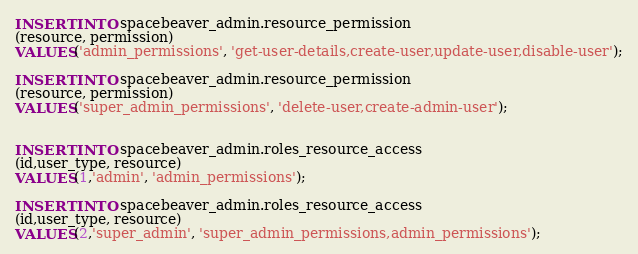<code> <loc_0><loc_0><loc_500><loc_500><_SQL_>INSERT INTO spacebeaver_admin.resource_permission
(resource, permission)
VALUES('admin_permissions', 'get-user-details,create-user,update-user,disable-user');

INSERT INTO spacebeaver_admin.resource_permission
(resource, permission)
VALUES('super_admin_permissions', 'delete-user,create-admin-user');


INSERT INTO spacebeaver_admin.roles_resource_access
(id,user_type, resource)
VALUES(1,'admin', 'admin_permissions');

INSERT INTO spacebeaver_admin.roles_resource_access
(id,user_type, resource)
VALUES(2,'super_admin', 'super_admin_permissions,admin_permissions');</code> 